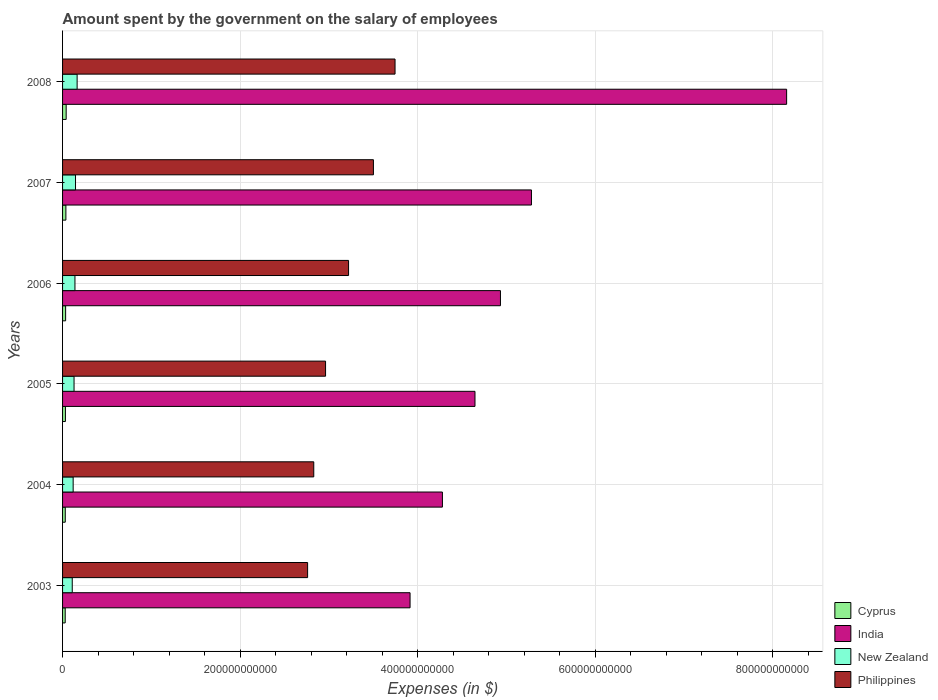Are the number of bars per tick equal to the number of legend labels?
Offer a terse response. Yes. How many bars are there on the 5th tick from the top?
Offer a very short reply. 4. What is the label of the 3rd group of bars from the top?
Your answer should be compact. 2006. In how many cases, is the number of bars for a given year not equal to the number of legend labels?
Give a very brief answer. 0. What is the amount spent on the salary of employees by the government in New Zealand in 2006?
Provide a succinct answer. 1.40e+1. Across all years, what is the maximum amount spent on the salary of employees by the government in India?
Give a very brief answer. 8.16e+11. Across all years, what is the minimum amount spent on the salary of employees by the government in Cyprus?
Provide a short and direct response. 2.97e+09. What is the total amount spent on the salary of employees by the government in New Zealand in the graph?
Make the answer very short. 8.07e+1. What is the difference between the amount spent on the salary of employees by the government in Cyprus in 2003 and that in 2006?
Offer a very short reply. -4.78e+08. What is the difference between the amount spent on the salary of employees by the government in India in 2004 and the amount spent on the salary of employees by the government in New Zealand in 2006?
Ensure brevity in your answer.  4.14e+11. What is the average amount spent on the salary of employees by the government in Philippines per year?
Ensure brevity in your answer.  3.17e+11. In the year 2004, what is the difference between the amount spent on the salary of employees by the government in New Zealand and amount spent on the salary of employees by the government in India?
Offer a very short reply. -4.16e+11. In how many years, is the amount spent on the salary of employees by the government in New Zealand greater than 480000000000 $?
Provide a succinct answer. 0. What is the ratio of the amount spent on the salary of employees by the government in Philippines in 2006 to that in 2007?
Offer a very short reply. 0.92. Is the amount spent on the salary of employees by the government in India in 2003 less than that in 2005?
Offer a very short reply. Yes. Is the difference between the amount spent on the salary of employees by the government in New Zealand in 2003 and 2008 greater than the difference between the amount spent on the salary of employees by the government in India in 2003 and 2008?
Offer a terse response. Yes. What is the difference between the highest and the second highest amount spent on the salary of employees by the government in India?
Your response must be concise. 2.88e+11. What is the difference between the highest and the lowest amount spent on the salary of employees by the government in New Zealand?
Give a very brief answer. 5.49e+09. In how many years, is the amount spent on the salary of employees by the government in Philippines greater than the average amount spent on the salary of employees by the government in Philippines taken over all years?
Your response must be concise. 3. What does the 4th bar from the top in 2005 represents?
Give a very brief answer. Cyprus. What does the 3rd bar from the bottom in 2008 represents?
Provide a succinct answer. New Zealand. What is the difference between two consecutive major ticks on the X-axis?
Offer a terse response. 2.00e+11. Does the graph contain any zero values?
Your answer should be very brief. No. Does the graph contain grids?
Give a very brief answer. Yes. How many legend labels are there?
Provide a short and direct response. 4. How are the legend labels stacked?
Make the answer very short. Vertical. What is the title of the graph?
Keep it short and to the point. Amount spent by the government on the salary of employees. Does "European Union" appear as one of the legend labels in the graph?
Your response must be concise. No. What is the label or title of the X-axis?
Provide a short and direct response. Expenses (in $). What is the label or title of the Y-axis?
Provide a succinct answer. Years. What is the Expenses (in $) in Cyprus in 2003?
Offer a terse response. 2.97e+09. What is the Expenses (in $) in India in 2003?
Your response must be concise. 3.92e+11. What is the Expenses (in $) in New Zealand in 2003?
Provide a succinct answer. 1.09e+1. What is the Expenses (in $) in Philippines in 2003?
Keep it short and to the point. 2.76e+11. What is the Expenses (in $) of Cyprus in 2004?
Give a very brief answer. 3.05e+09. What is the Expenses (in $) in India in 2004?
Give a very brief answer. 4.28e+11. What is the Expenses (in $) of New Zealand in 2004?
Your response must be concise. 1.19e+1. What is the Expenses (in $) in Philippines in 2004?
Give a very brief answer. 2.83e+11. What is the Expenses (in $) of Cyprus in 2005?
Your answer should be compact. 3.22e+09. What is the Expenses (in $) in India in 2005?
Keep it short and to the point. 4.65e+11. What is the Expenses (in $) of New Zealand in 2005?
Ensure brevity in your answer.  1.29e+1. What is the Expenses (in $) in Philippines in 2005?
Your response must be concise. 2.96e+11. What is the Expenses (in $) in Cyprus in 2006?
Make the answer very short. 3.45e+09. What is the Expenses (in $) in India in 2006?
Make the answer very short. 4.93e+11. What is the Expenses (in $) of New Zealand in 2006?
Offer a very short reply. 1.40e+1. What is the Expenses (in $) of Philippines in 2006?
Keep it short and to the point. 3.22e+11. What is the Expenses (in $) of Cyprus in 2007?
Keep it short and to the point. 3.74e+09. What is the Expenses (in $) in India in 2007?
Offer a terse response. 5.28e+11. What is the Expenses (in $) of New Zealand in 2007?
Your answer should be compact. 1.46e+1. What is the Expenses (in $) of Philippines in 2007?
Provide a succinct answer. 3.50e+11. What is the Expenses (in $) in Cyprus in 2008?
Ensure brevity in your answer.  4.06e+09. What is the Expenses (in $) in India in 2008?
Make the answer very short. 8.16e+11. What is the Expenses (in $) of New Zealand in 2008?
Make the answer very short. 1.64e+1. What is the Expenses (in $) in Philippines in 2008?
Your answer should be very brief. 3.75e+11. Across all years, what is the maximum Expenses (in $) of Cyprus?
Provide a short and direct response. 4.06e+09. Across all years, what is the maximum Expenses (in $) of India?
Your response must be concise. 8.16e+11. Across all years, what is the maximum Expenses (in $) of New Zealand?
Provide a short and direct response. 1.64e+1. Across all years, what is the maximum Expenses (in $) in Philippines?
Your answer should be very brief. 3.75e+11. Across all years, what is the minimum Expenses (in $) of Cyprus?
Ensure brevity in your answer.  2.97e+09. Across all years, what is the minimum Expenses (in $) in India?
Ensure brevity in your answer.  3.92e+11. Across all years, what is the minimum Expenses (in $) of New Zealand?
Give a very brief answer. 1.09e+1. Across all years, what is the minimum Expenses (in $) of Philippines?
Offer a very short reply. 2.76e+11. What is the total Expenses (in $) in Cyprus in the graph?
Your response must be concise. 2.05e+1. What is the total Expenses (in $) in India in the graph?
Your answer should be compact. 3.12e+12. What is the total Expenses (in $) in New Zealand in the graph?
Keep it short and to the point. 8.07e+1. What is the total Expenses (in $) in Philippines in the graph?
Offer a terse response. 1.90e+12. What is the difference between the Expenses (in $) of Cyprus in 2003 and that in 2004?
Offer a very short reply. -7.69e+07. What is the difference between the Expenses (in $) in India in 2003 and that in 2004?
Give a very brief answer. -3.65e+1. What is the difference between the Expenses (in $) of New Zealand in 2003 and that in 2004?
Make the answer very short. -1.02e+09. What is the difference between the Expenses (in $) of Philippines in 2003 and that in 2004?
Ensure brevity in your answer.  -6.94e+09. What is the difference between the Expenses (in $) in Cyprus in 2003 and that in 2005?
Your answer should be very brief. -2.44e+08. What is the difference between the Expenses (in $) of India in 2003 and that in 2005?
Your answer should be very brief. -7.32e+1. What is the difference between the Expenses (in $) in New Zealand in 2003 and that in 2005?
Your response must be concise. -2.02e+09. What is the difference between the Expenses (in $) in Philippines in 2003 and that in 2005?
Your response must be concise. -2.02e+1. What is the difference between the Expenses (in $) in Cyprus in 2003 and that in 2006?
Provide a succinct answer. -4.78e+08. What is the difference between the Expenses (in $) in India in 2003 and that in 2006?
Offer a terse response. -1.02e+11. What is the difference between the Expenses (in $) in New Zealand in 2003 and that in 2006?
Keep it short and to the point. -3.04e+09. What is the difference between the Expenses (in $) of Philippines in 2003 and that in 2006?
Your answer should be compact. -4.61e+1. What is the difference between the Expenses (in $) of Cyprus in 2003 and that in 2007?
Your response must be concise. -7.74e+08. What is the difference between the Expenses (in $) of India in 2003 and that in 2007?
Make the answer very short. -1.37e+11. What is the difference between the Expenses (in $) in New Zealand in 2003 and that in 2007?
Provide a short and direct response. -3.68e+09. What is the difference between the Expenses (in $) of Philippines in 2003 and that in 2007?
Your answer should be very brief. -7.42e+1. What is the difference between the Expenses (in $) in Cyprus in 2003 and that in 2008?
Make the answer very short. -1.08e+09. What is the difference between the Expenses (in $) in India in 2003 and that in 2008?
Your response must be concise. -4.24e+11. What is the difference between the Expenses (in $) in New Zealand in 2003 and that in 2008?
Your response must be concise. -5.49e+09. What is the difference between the Expenses (in $) in Philippines in 2003 and that in 2008?
Your answer should be very brief. -9.85e+1. What is the difference between the Expenses (in $) of Cyprus in 2004 and that in 2005?
Your answer should be compact. -1.67e+08. What is the difference between the Expenses (in $) of India in 2004 and that in 2005?
Make the answer very short. -3.67e+1. What is the difference between the Expenses (in $) in New Zealand in 2004 and that in 2005?
Offer a very short reply. -9.98e+08. What is the difference between the Expenses (in $) in Philippines in 2004 and that in 2005?
Ensure brevity in your answer.  -1.33e+1. What is the difference between the Expenses (in $) of Cyprus in 2004 and that in 2006?
Provide a succinct answer. -4.01e+08. What is the difference between the Expenses (in $) of India in 2004 and that in 2006?
Your answer should be very brief. -6.54e+1. What is the difference between the Expenses (in $) in New Zealand in 2004 and that in 2006?
Your answer should be very brief. -2.02e+09. What is the difference between the Expenses (in $) of Philippines in 2004 and that in 2006?
Offer a very short reply. -3.92e+1. What is the difference between the Expenses (in $) in Cyprus in 2004 and that in 2007?
Give a very brief answer. -6.97e+08. What is the difference between the Expenses (in $) of India in 2004 and that in 2007?
Your answer should be very brief. -1.00e+11. What is the difference between the Expenses (in $) in New Zealand in 2004 and that in 2007?
Ensure brevity in your answer.  -2.66e+09. What is the difference between the Expenses (in $) of Philippines in 2004 and that in 2007?
Ensure brevity in your answer.  -6.72e+1. What is the difference between the Expenses (in $) of Cyprus in 2004 and that in 2008?
Your answer should be very brief. -1.01e+09. What is the difference between the Expenses (in $) of India in 2004 and that in 2008?
Your response must be concise. -3.88e+11. What is the difference between the Expenses (in $) of New Zealand in 2004 and that in 2008?
Offer a terse response. -4.47e+09. What is the difference between the Expenses (in $) in Philippines in 2004 and that in 2008?
Offer a terse response. -9.16e+1. What is the difference between the Expenses (in $) in Cyprus in 2005 and that in 2006?
Your response must be concise. -2.33e+08. What is the difference between the Expenses (in $) of India in 2005 and that in 2006?
Make the answer very short. -2.87e+1. What is the difference between the Expenses (in $) in New Zealand in 2005 and that in 2006?
Provide a short and direct response. -1.02e+09. What is the difference between the Expenses (in $) in Philippines in 2005 and that in 2006?
Your answer should be compact. -2.59e+1. What is the difference between the Expenses (in $) of Cyprus in 2005 and that in 2007?
Your response must be concise. -5.29e+08. What is the difference between the Expenses (in $) in India in 2005 and that in 2007?
Give a very brief answer. -6.36e+1. What is the difference between the Expenses (in $) of New Zealand in 2005 and that in 2007?
Your response must be concise. -1.66e+09. What is the difference between the Expenses (in $) in Philippines in 2005 and that in 2007?
Ensure brevity in your answer.  -5.39e+1. What is the difference between the Expenses (in $) of Cyprus in 2005 and that in 2008?
Give a very brief answer. -8.40e+08. What is the difference between the Expenses (in $) of India in 2005 and that in 2008?
Offer a very short reply. -3.51e+11. What is the difference between the Expenses (in $) of New Zealand in 2005 and that in 2008?
Give a very brief answer. -3.47e+09. What is the difference between the Expenses (in $) of Philippines in 2005 and that in 2008?
Provide a short and direct response. -7.83e+1. What is the difference between the Expenses (in $) in Cyprus in 2006 and that in 2007?
Your response must be concise. -2.96e+08. What is the difference between the Expenses (in $) in India in 2006 and that in 2007?
Your response must be concise. -3.49e+1. What is the difference between the Expenses (in $) in New Zealand in 2006 and that in 2007?
Provide a short and direct response. -6.46e+08. What is the difference between the Expenses (in $) in Philippines in 2006 and that in 2007?
Provide a succinct answer. -2.80e+1. What is the difference between the Expenses (in $) of Cyprus in 2006 and that in 2008?
Offer a terse response. -6.06e+08. What is the difference between the Expenses (in $) in India in 2006 and that in 2008?
Ensure brevity in your answer.  -3.22e+11. What is the difference between the Expenses (in $) in New Zealand in 2006 and that in 2008?
Provide a short and direct response. -2.45e+09. What is the difference between the Expenses (in $) of Philippines in 2006 and that in 2008?
Provide a succinct answer. -5.24e+1. What is the difference between the Expenses (in $) in Cyprus in 2007 and that in 2008?
Offer a very short reply. -3.10e+08. What is the difference between the Expenses (in $) in India in 2007 and that in 2008?
Your answer should be compact. -2.88e+11. What is the difference between the Expenses (in $) of New Zealand in 2007 and that in 2008?
Your response must be concise. -1.80e+09. What is the difference between the Expenses (in $) of Philippines in 2007 and that in 2008?
Your answer should be very brief. -2.44e+1. What is the difference between the Expenses (in $) of Cyprus in 2003 and the Expenses (in $) of India in 2004?
Your response must be concise. -4.25e+11. What is the difference between the Expenses (in $) in Cyprus in 2003 and the Expenses (in $) in New Zealand in 2004?
Make the answer very short. -8.97e+09. What is the difference between the Expenses (in $) in Cyprus in 2003 and the Expenses (in $) in Philippines in 2004?
Provide a succinct answer. -2.80e+11. What is the difference between the Expenses (in $) in India in 2003 and the Expenses (in $) in New Zealand in 2004?
Ensure brevity in your answer.  3.80e+11. What is the difference between the Expenses (in $) of India in 2003 and the Expenses (in $) of Philippines in 2004?
Your response must be concise. 1.09e+11. What is the difference between the Expenses (in $) of New Zealand in 2003 and the Expenses (in $) of Philippines in 2004?
Make the answer very short. -2.72e+11. What is the difference between the Expenses (in $) of Cyprus in 2003 and the Expenses (in $) of India in 2005?
Offer a terse response. -4.62e+11. What is the difference between the Expenses (in $) of Cyprus in 2003 and the Expenses (in $) of New Zealand in 2005?
Your answer should be compact. -9.97e+09. What is the difference between the Expenses (in $) in Cyprus in 2003 and the Expenses (in $) in Philippines in 2005?
Give a very brief answer. -2.93e+11. What is the difference between the Expenses (in $) in India in 2003 and the Expenses (in $) in New Zealand in 2005?
Offer a very short reply. 3.79e+11. What is the difference between the Expenses (in $) in India in 2003 and the Expenses (in $) in Philippines in 2005?
Offer a very short reply. 9.52e+1. What is the difference between the Expenses (in $) of New Zealand in 2003 and the Expenses (in $) of Philippines in 2005?
Your response must be concise. -2.85e+11. What is the difference between the Expenses (in $) in Cyprus in 2003 and the Expenses (in $) in India in 2006?
Your answer should be compact. -4.90e+11. What is the difference between the Expenses (in $) of Cyprus in 2003 and the Expenses (in $) of New Zealand in 2006?
Provide a short and direct response. -1.10e+1. What is the difference between the Expenses (in $) in Cyprus in 2003 and the Expenses (in $) in Philippines in 2006?
Make the answer very short. -3.19e+11. What is the difference between the Expenses (in $) in India in 2003 and the Expenses (in $) in New Zealand in 2006?
Keep it short and to the point. 3.78e+11. What is the difference between the Expenses (in $) in India in 2003 and the Expenses (in $) in Philippines in 2006?
Offer a terse response. 6.93e+1. What is the difference between the Expenses (in $) of New Zealand in 2003 and the Expenses (in $) of Philippines in 2006?
Give a very brief answer. -3.11e+11. What is the difference between the Expenses (in $) of Cyprus in 2003 and the Expenses (in $) of India in 2007?
Make the answer very short. -5.25e+11. What is the difference between the Expenses (in $) in Cyprus in 2003 and the Expenses (in $) in New Zealand in 2007?
Your answer should be compact. -1.16e+1. What is the difference between the Expenses (in $) of Cyprus in 2003 and the Expenses (in $) of Philippines in 2007?
Provide a succinct answer. -3.47e+11. What is the difference between the Expenses (in $) of India in 2003 and the Expenses (in $) of New Zealand in 2007?
Keep it short and to the point. 3.77e+11. What is the difference between the Expenses (in $) of India in 2003 and the Expenses (in $) of Philippines in 2007?
Keep it short and to the point. 4.13e+1. What is the difference between the Expenses (in $) in New Zealand in 2003 and the Expenses (in $) in Philippines in 2007?
Offer a terse response. -3.39e+11. What is the difference between the Expenses (in $) in Cyprus in 2003 and the Expenses (in $) in India in 2008?
Your answer should be compact. -8.13e+11. What is the difference between the Expenses (in $) in Cyprus in 2003 and the Expenses (in $) in New Zealand in 2008?
Make the answer very short. -1.34e+1. What is the difference between the Expenses (in $) in Cyprus in 2003 and the Expenses (in $) in Philippines in 2008?
Your answer should be very brief. -3.72e+11. What is the difference between the Expenses (in $) of India in 2003 and the Expenses (in $) of New Zealand in 2008?
Offer a terse response. 3.75e+11. What is the difference between the Expenses (in $) of India in 2003 and the Expenses (in $) of Philippines in 2008?
Provide a short and direct response. 1.69e+1. What is the difference between the Expenses (in $) of New Zealand in 2003 and the Expenses (in $) of Philippines in 2008?
Keep it short and to the point. -3.64e+11. What is the difference between the Expenses (in $) of Cyprus in 2004 and the Expenses (in $) of India in 2005?
Make the answer very short. -4.62e+11. What is the difference between the Expenses (in $) of Cyprus in 2004 and the Expenses (in $) of New Zealand in 2005?
Offer a very short reply. -9.89e+09. What is the difference between the Expenses (in $) in Cyprus in 2004 and the Expenses (in $) in Philippines in 2005?
Your answer should be very brief. -2.93e+11. What is the difference between the Expenses (in $) of India in 2004 and the Expenses (in $) of New Zealand in 2005?
Make the answer very short. 4.15e+11. What is the difference between the Expenses (in $) of India in 2004 and the Expenses (in $) of Philippines in 2005?
Your answer should be compact. 1.32e+11. What is the difference between the Expenses (in $) in New Zealand in 2004 and the Expenses (in $) in Philippines in 2005?
Your answer should be very brief. -2.84e+11. What is the difference between the Expenses (in $) of Cyprus in 2004 and the Expenses (in $) of India in 2006?
Your response must be concise. -4.90e+11. What is the difference between the Expenses (in $) in Cyprus in 2004 and the Expenses (in $) in New Zealand in 2006?
Keep it short and to the point. -1.09e+1. What is the difference between the Expenses (in $) in Cyprus in 2004 and the Expenses (in $) in Philippines in 2006?
Provide a succinct answer. -3.19e+11. What is the difference between the Expenses (in $) of India in 2004 and the Expenses (in $) of New Zealand in 2006?
Your response must be concise. 4.14e+11. What is the difference between the Expenses (in $) in India in 2004 and the Expenses (in $) in Philippines in 2006?
Make the answer very short. 1.06e+11. What is the difference between the Expenses (in $) in New Zealand in 2004 and the Expenses (in $) in Philippines in 2006?
Your answer should be very brief. -3.10e+11. What is the difference between the Expenses (in $) in Cyprus in 2004 and the Expenses (in $) in India in 2007?
Make the answer very short. -5.25e+11. What is the difference between the Expenses (in $) of Cyprus in 2004 and the Expenses (in $) of New Zealand in 2007?
Your response must be concise. -1.16e+1. What is the difference between the Expenses (in $) in Cyprus in 2004 and the Expenses (in $) in Philippines in 2007?
Offer a very short reply. -3.47e+11. What is the difference between the Expenses (in $) of India in 2004 and the Expenses (in $) of New Zealand in 2007?
Ensure brevity in your answer.  4.13e+11. What is the difference between the Expenses (in $) in India in 2004 and the Expenses (in $) in Philippines in 2007?
Provide a short and direct response. 7.77e+1. What is the difference between the Expenses (in $) in New Zealand in 2004 and the Expenses (in $) in Philippines in 2007?
Your answer should be compact. -3.38e+11. What is the difference between the Expenses (in $) in Cyprus in 2004 and the Expenses (in $) in India in 2008?
Your response must be concise. -8.13e+11. What is the difference between the Expenses (in $) in Cyprus in 2004 and the Expenses (in $) in New Zealand in 2008?
Your answer should be very brief. -1.34e+1. What is the difference between the Expenses (in $) in Cyprus in 2004 and the Expenses (in $) in Philippines in 2008?
Keep it short and to the point. -3.72e+11. What is the difference between the Expenses (in $) in India in 2004 and the Expenses (in $) in New Zealand in 2008?
Your answer should be very brief. 4.12e+11. What is the difference between the Expenses (in $) in India in 2004 and the Expenses (in $) in Philippines in 2008?
Your answer should be compact. 5.34e+1. What is the difference between the Expenses (in $) in New Zealand in 2004 and the Expenses (in $) in Philippines in 2008?
Ensure brevity in your answer.  -3.63e+11. What is the difference between the Expenses (in $) in Cyprus in 2005 and the Expenses (in $) in India in 2006?
Offer a very short reply. -4.90e+11. What is the difference between the Expenses (in $) in Cyprus in 2005 and the Expenses (in $) in New Zealand in 2006?
Your answer should be compact. -1.07e+1. What is the difference between the Expenses (in $) of Cyprus in 2005 and the Expenses (in $) of Philippines in 2006?
Provide a succinct answer. -3.19e+11. What is the difference between the Expenses (in $) in India in 2005 and the Expenses (in $) in New Zealand in 2006?
Provide a succinct answer. 4.51e+11. What is the difference between the Expenses (in $) of India in 2005 and the Expenses (in $) of Philippines in 2006?
Your answer should be compact. 1.42e+11. What is the difference between the Expenses (in $) in New Zealand in 2005 and the Expenses (in $) in Philippines in 2006?
Provide a short and direct response. -3.09e+11. What is the difference between the Expenses (in $) in Cyprus in 2005 and the Expenses (in $) in India in 2007?
Your answer should be very brief. -5.25e+11. What is the difference between the Expenses (in $) of Cyprus in 2005 and the Expenses (in $) of New Zealand in 2007?
Your answer should be compact. -1.14e+1. What is the difference between the Expenses (in $) of Cyprus in 2005 and the Expenses (in $) of Philippines in 2007?
Give a very brief answer. -3.47e+11. What is the difference between the Expenses (in $) of India in 2005 and the Expenses (in $) of New Zealand in 2007?
Offer a terse response. 4.50e+11. What is the difference between the Expenses (in $) of India in 2005 and the Expenses (in $) of Philippines in 2007?
Ensure brevity in your answer.  1.14e+11. What is the difference between the Expenses (in $) of New Zealand in 2005 and the Expenses (in $) of Philippines in 2007?
Ensure brevity in your answer.  -3.37e+11. What is the difference between the Expenses (in $) in Cyprus in 2005 and the Expenses (in $) in India in 2008?
Your answer should be compact. -8.13e+11. What is the difference between the Expenses (in $) of Cyprus in 2005 and the Expenses (in $) of New Zealand in 2008?
Offer a terse response. -1.32e+1. What is the difference between the Expenses (in $) in Cyprus in 2005 and the Expenses (in $) in Philippines in 2008?
Provide a short and direct response. -3.71e+11. What is the difference between the Expenses (in $) of India in 2005 and the Expenses (in $) of New Zealand in 2008?
Offer a very short reply. 4.48e+11. What is the difference between the Expenses (in $) of India in 2005 and the Expenses (in $) of Philippines in 2008?
Your answer should be very brief. 9.01e+1. What is the difference between the Expenses (in $) of New Zealand in 2005 and the Expenses (in $) of Philippines in 2008?
Your response must be concise. -3.62e+11. What is the difference between the Expenses (in $) in Cyprus in 2006 and the Expenses (in $) in India in 2007?
Make the answer very short. -5.25e+11. What is the difference between the Expenses (in $) of Cyprus in 2006 and the Expenses (in $) of New Zealand in 2007?
Your answer should be very brief. -1.12e+1. What is the difference between the Expenses (in $) in Cyprus in 2006 and the Expenses (in $) in Philippines in 2007?
Your answer should be very brief. -3.47e+11. What is the difference between the Expenses (in $) in India in 2006 and the Expenses (in $) in New Zealand in 2007?
Your response must be concise. 4.79e+11. What is the difference between the Expenses (in $) in India in 2006 and the Expenses (in $) in Philippines in 2007?
Your answer should be compact. 1.43e+11. What is the difference between the Expenses (in $) in New Zealand in 2006 and the Expenses (in $) in Philippines in 2007?
Offer a terse response. -3.36e+11. What is the difference between the Expenses (in $) of Cyprus in 2006 and the Expenses (in $) of India in 2008?
Offer a very short reply. -8.12e+11. What is the difference between the Expenses (in $) of Cyprus in 2006 and the Expenses (in $) of New Zealand in 2008?
Keep it short and to the point. -1.30e+1. What is the difference between the Expenses (in $) in Cyprus in 2006 and the Expenses (in $) in Philippines in 2008?
Offer a terse response. -3.71e+11. What is the difference between the Expenses (in $) in India in 2006 and the Expenses (in $) in New Zealand in 2008?
Your response must be concise. 4.77e+11. What is the difference between the Expenses (in $) of India in 2006 and the Expenses (in $) of Philippines in 2008?
Make the answer very short. 1.19e+11. What is the difference between the Expenses (in $) in New Zealand in 2006 and the Expenses (in $) in Philippines in 2008?
Provide a short and direct response. -3.61e+11. What is the difference between the Expenses (in $) in Cyprus in 2007 and the Expenses (in $) in India in 2008?
Offer a very short reply. -8.12e+11. What is the difference between the Expenses (in $) of Cyprus in 2007 and the Expenses (in $) of New Zealand in 2008?
Keep it short and to the point. -1.27e+1. What is the difference between the Expenses (in $) in Cyprus in 2007 and the Expenses (in $) in Philippines in 2008?
Give a very brief answer. -3.71e+11. What is the difference between the Expenses (in $) in India in 2007 and the Expenses (in $) in New Zealand in 2008?
Provide a succinct answer. 5.12e+11. What is the difference between the Expenses (in $) in India in 2007 and the Expenses (in $) in Philippines in 2008?
Offer a very short reply. 1.54e+11. What is the difference between the Expenses (in $) in New Zealand in 2007 and the Expenses (in $) in Philippines in 2008?
Provide a succinct answer. -3.60e+11. What is the average Expenses (in $) in Cyprus per year?
Your answer should be very brief. 3.41e+09. What is the average Expenses (in $) of India per year?
Provide a short and direct response. 5.20e+11. What is the average Expenses (in $) in New Zealand per year?
Your response must be concise. 1.35e+1. What is the average Expenses (in $) in Philippines per year?
Keep it short and to the point. 3.17e+11. In the year 2003, what is the difference between the Expenses (in $) of Cyprus and Expenses (in $) of India?
Keep it short and to the point. -3.89e+11. In the year 2003, what is the difference between the Expenses (in $) of Cyprus and Expenses (in $) of New Zealand?
Offer a very short reply. -7.94e+09. In the year 2003, what is the difference between the Expenses (in $) in Cyprus and Expenses (in $) in Philippines?
Your answer should be compact. -2.73e+11. In the year 2003, what is the difference between the Expenses (in $) of India and Expenses (in $) of New Zealand?
Keep it short and to the point. 3.81e+11. In the year 2003, what is the difference between the Expenses (in $) of India and Expenses (in $) of Philippines?
Give a very brief answer. 1.15e+11. In the year 2003, what is the difference between the Expenses (in $) of New Zealand and Expenses (in $) of Philippines?
Your response must be concise. -2.65e+11. In the year 2004, what is the difference between the Expenses (in $) of Cyprus and Expenses (in $) of India?
Your answer should be compact. -4.25e+11. In the year 2004, what is the difference between the Expenses (in $) in Cyprus and Expenses (in $) in New Zealand?
Provide a short and direct response. -8.89e+09. In the year 2004, what is the difference between the Expenses (in $) in Cyprus and Expenses (in $) in Philippines?
Keep it short and to the point. -2.80e+11. In the year 2004, what is the difference between the Expenses (in $) in India and Expenses (in $) in New Zealand?
Keep it short and to the point. 4.16e+11. In the year 2004, what is the difference between the Expenses (in $) in India and Expenses (in $) in Philippines?
Ensure brevity in your answer.  1.45e+11. In the year 2004, what is the difference between the Expenses (in $) of New Zealand and Expenses (in $) of Philippines?
Offer a terse response. -2.71e+11. In the year 2005, what is the difference between the Expenses (in $) of Cyprus and Expenses (in $) of India?
Provide a short and direct response. -4.62e+11. In the year 2005, what is the difference between the Expenses (in $) in Cyprus and Expenses (in $) in New Zealand?
Your response must be concise. -9.72e+09. In the year 2005, what is the difference between the Expenses (in $) in Cyprus and Expenses (in $) in Philippines?
Your response must be concise. -2.93e+11. In the year 2005, what is the difference between the Expenses (in $) of India and Expenses (in $) of New Zealand?
Your answer should be very brief. 4.52e+11. In the year 2005, what is the difference between the Expenses (in $) of India and Expenses (in $) of Philippines?
Give a very brief answer. 1.68e+11. In the year 2005, what is the difference between the Expenses (in $) of New Zealand and Expenses (in $) of Philippines?
Provide a short and direct response. -2.83e+11. In the year 2006, what is the difference between the Expenses (in $) of Cyprus and Expenses (in $) of India?
Your answer should be very brief. -4.90e+11. In the year 2006, what is the difference between the Expenses (in $) of Cyprus and Expenses (in $) of New Zealand?
Your answer should be compact. -1.05e+1. In the year 2006, what is the difference between the Expenses (in $) of Cyprus and Expenses (in $) of Philippines?
Your answer should be very brief. -3.19e+11. In the year 2006, what is the difference between the Expenses (in $) of India and Expenses (in $) of New Zealand?
Your response must be concise. 4.79e+11. In the year 2006, what is the difference between the Expenses (in $) of India and Expenses (in $) of Philippines?
Offer a terse response. 1.71e+11. In the year 2006, what is the difference between the Expenses (in $) of New Zealand and Expenses (in $) of Philippines?
Provide a succinct answer. -3.08e+11. In the year 2007, what is the difference between the Expenses (in $) in Cyprus and Expenses (in $) in India?
Your answer should be very brief. -5.25e+11. In the year 2007, what is the difference between the Expenses (in $) of Cyprus and Expenses (in $) of New Zealand?
Provide a short and direct response. -1.09e+1. In the year 2007, what is the difference between the Expenses (in $) of Cyprus and Expenses (in $) of Philippines?
Make the answer very short. -3.47e+11. In the year 2007, what is the difference between the Expenses (in $) in India and Expenses (in $) in New Zealand?
Offer a very short reply. 5.14e+11. In the year 2007, what is the difference between the Expenses (in $) in India and Expenses (in $) in Philippines?
Your response must be concise. 1.78e+11. In the year 2007, what is the difference between the Expenses (in $) in New Zealand and Expenses (in $) in Philippines?
Give a very brief answer. -3.36e+11. In the year 2008, what is the difference between the Expenses (in $) of Cyprus and Expenses (in $) of India?
Give a very brief answer. -8.12e+11. In the year 2008, what is the difference between the Expenses (in $) in Cyprus and Expenses (in $) in New Zealand?
Your answer should be compact. -1.23e+1. In the year 2008, what is the difference between the Expenses (in $) in Cyprus and Expenses (in $) in Philippines?
Offer a very short reply. -3.71e+11. In the year 2008, what is the difference between the Expenses (in $) in India and Expenses (in $) in New Zealand?
Offer a terse response. 8.00e+11. In the year 2008, what is the difference between the Expenses (in $) in India and Expenses (in $) in Philippines?
Make the answer very short. 4.41e+11. In the year 2008, what is the difference between the Expenses (in $) of New Zealand and Expenses (in $) of Philippines?
Give a very brief answer. -3.58e+11. What is the ratio of the Expenses (in $) in Cyprus in 2003 to that in 2004?
Offer a very short reply. 0.97. What is the ratio of the Expenses (in $) in India in 2003 to that in 2004?
Give a very brief answer. 0.91. What is the ratio of the Expenses (in $) in New Zealand in 2003 to that in 2004?
Your answer should be very brief. 0.91. What is the ratio of the Expenses (in $) of Philippines in 2003 to that in 2004?
Your response must be concise. 0.98. What is the ratio of the Expenses (in $) in Cyprus in 2003 to that in 2005?
Offer a terse response. 0.92. What is the ratio of the Expenses (in $) of India in 2003 to that in 2005?
Your answer should be compact. 0.84. What is the ratio of the Expenses (in $) of New Zealand in 2003 to that in 2005?
Keep it short and to the point. 0.84. What is the ratio of the Expenses (in $) of Philippines in 2003 to that in 2005?
Your answer should be compact. 0.93. What is the ratio of the Expenses (in $) of Cyprus in 2003 to that in 2006?
Your response must be concise. 0.86. What is the ratio of the Expenses (in $) of India in 2003 to that in 2006?
Offer a terse response. 0.79. What is the ratio of the Expenses (in $) of New Zealand in 2003 to that in 2006?
Offer a terse response. 0.78. What is the ratio of the Expenses (in $) of Philippines in 2003 to that in 2006?
Your answer should be compact. 0.86. What is the ratio of the Expenses (in $) in Cyprus in 2003 to that in 2007?
Offer a terse response. 0.79. What is the ratio of the Expenses (in $) in India in 2003 to that in 2007?
Provide a succinct answer. 0.74. What is the ratio of the Expenses (in $) of New Zealand in 2003 to that in 2007?
Offer a very short reply. 0.75. What is the ratio of the Expenses (in $) in Philippines in 2003 to that in 2007?
Offer a terse response. 0.79. What is the ratio of the Expenses (in $) in Cyprus in 2003 to that in 2008?
Your response must be concise. 0.73. What is the ratio of the Expenses (in $) in India in 2003 to that in 2008?
Provide a succinct answer. 0.48. What is the ratio of the Expenses (in $) in New Zealand in 2003 to that in 2008?
Give a very brief answer. 0.67. What is the ratio of the Expenses (in $) in Philippines in 2003 to that in 2008?
Keep it short and to the point. 0.74. What is the ratio of the Expenses (in $) in Cyprus in 2004 to that in 2005?
Your answer should be compact. 0.95. What is the ratio of the Expenses (in $) of India in 2004 to that in 2005?
Your answer should be very brief. 0.92. What is the ratio of the Expenses (in $) in New Zealand in 2004 to that in 2005?
Provide a succinct answer. 0.92. What is the ratio of the Expenses (in $) in Philippines in 2004 to that in 2005?
Ensure brevity in your answer.  0.96. What is the ratio of the Expenses (in $) of Cyprus in 2004 to that in 2006?
Your response must be concise. 0.88. What is the ratio of the Expenses (in $) of India in 2004 to that in 2006?
Provide a short and direct response. 0.87. What is the ratio of the Expenses (in $) of New Zealand in 2004 to that in 2006?
Your answer should be compact. 0.86. What is the ratio of the Expenses (in $) in Philippines in 2004 to that in 2006?
Your response must be concise. 0.88. What is the ratio of the Expenses (in $) of Cyprus in 2004 to that in 2007?
Ensure brevity in your answer.  0.81. What is the ratio of the Expenses (in $) in India in 2004 to that in 2007?
Give a very brief answer. 0.81. What is the ratio of the Expenses (in $) in New Zealand in 2004 to that in 2007?
Your answer should be very brief. 0.82. What is the ratio of the Expenses (in $) of Philippines in 2004 to that in 2007?
Make the answer very short. 0.81. What is the ratio of the Expenses (in $) in Cyprus in 2004 to that in 2008?
Provide a succinct answer. 0.75. What is the ratio of the Expenses (in $) of India in 2004 to that in 2008?
Provide a succinct answer. 0.52. What is the ratio of the Expenses (in $) of New Zealand in 2004 to that in 2008?
Give a very brief answer. 0.73. What is the ratio of the Expenses (in $) in Philippines in 2004 to that in 2008?
Offer a terse response. 0.76. What is the ratio of the Expenses (in $) of Cyprus in 2005 to that in 2006?
Provide a succinct answer. 0.93. What is the ratio of the Expenses (in $) in India in 2005 to that in 2006?
Provide a short and direct response. 0.94. What is the ratio of the Expenses (in $) in New Zealand in 2005 to that in 2006?
Your answer should be very brief. 0.93. What is the ratio of the Expenses (in $) of Philippines in 2005 to that in 2006?
Give a very brief answer. 0.92. What is the ratio of the Expenses (in $) in Cyprus in 2005 to that in 2007?
Provide a short and direct response. 0.86. What is the ratio of the Expenses (in $) of India in 2005 to that in 2007?
Make the answer very short. 0.88. What is the ratio of the Expenses (in $) in New Zealand in 2005 to that in 2007?
Your response must be concise. 0.89. What is the ratio of the Expenses (in $) of Philippines in 2005 to that in 2007?
Offer a very short reply. 0.85. What is the ratio of the Expenses (in $) of Cyprus in 2005 to that in 2008?
Keep it short and to the point. 0.79. What is the ratio of the Expenses (in $) in India in 2005 to that in 2008?
Make the answer very short. 0.57. What is the ratio of the Expenses (in $) in New Zealand in 2005 to that in 2008?
Offer a very short reply. 0.79. What is the ratio of the Expenses (in $) of Philippines in 2005 to that in 2008?
Provide a succinct answer. 0.79. What is the ratio of the Expenses (in $) in Cyprus in 2006 to that in 2007?
Ensure brevity in your answer.  0.92. What is the ratio of the Expenses (in $) of India in 2006 to that in 2007?
Ensure brevity in your answer.  0.93. What is the ratio of the Expenses (in $) of New Zealand in 2006 to that in 2007?
Ensure brevity in your answer.  0.96. What is the ratio of the Expenses (in $) of Philippines in 2006 to that in 2007?
Your answer should be very brief. 0.92. What is the ratio of the Expenses (in $) in Cyprus in 2006 to that in 2008?
Offer a terse response. 0.85. What is the ratio of the Expenses (in $) in India in 2006 to that in 2008?
Offer a terse response. 0.6. What is the ratio of the Expenses (in $) in New Zealand in 2006 to that in 2008?
Give a very brief answer. 0.85. What is the ratio of the Expenses (in $) of Philippines in 2006 to that in 2008?
Your answer should be very brief. 0.86. What is the ratio of the Expenses (in $) in Cyprus in 2007 to that in 2008?
Your answer should be compact. 0.92. What is the ratio of the Expenses (in $) of India in 2007 to that in 2008?
Offer a very short reply. 0.65. What is the ratio of the Expenses (in $) in New Zealand in 2007 to that in 2008?
Ensure brevity in your answer.  0.89. What is the ratio of the Expenses (in $) of Philippines in 2007 to that in 2008?
Provide a short and direct response. 0.94. What is the difference between the highest and the second highest Expenses (in $) of Cyprus?
Make the answer very short. 3.10e+08. What is the difference between the highest and the second highest Expenses (in $) in India?
Provide a succinct answer. 2.88e+11. What is the difference between the highest and the second highest Expenses (in $) in New Zealand?
Keep it short and to the point. 1.80e+09. What is the difference between the highest and the second highest Expenses (in $) in Philippines?
Make the answer very short. 2.44e+1. What is the difference between the highest and the lowest Expenses (in $) in Cyprus?
Provide a succinct answer. 1.08e+09. What is the difference between the highest and the lowest Expenses (in $) in India?
Provide a succinct answer. 4.24e+11. What is the difference between the highest and the lowest Expenses (in $) in New Zealand?
Your response must be concise. 5.49e+09. What is the difference between the highest and the lowest Expenses (in $) of Philippines?
Keep it short and to the point. 9.85e+1. 